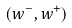Convert formula to latex. <formula><loc_0><loc_0><loc_500><loc_500>( w ^ { - } , w ^ { + } )</formula> 